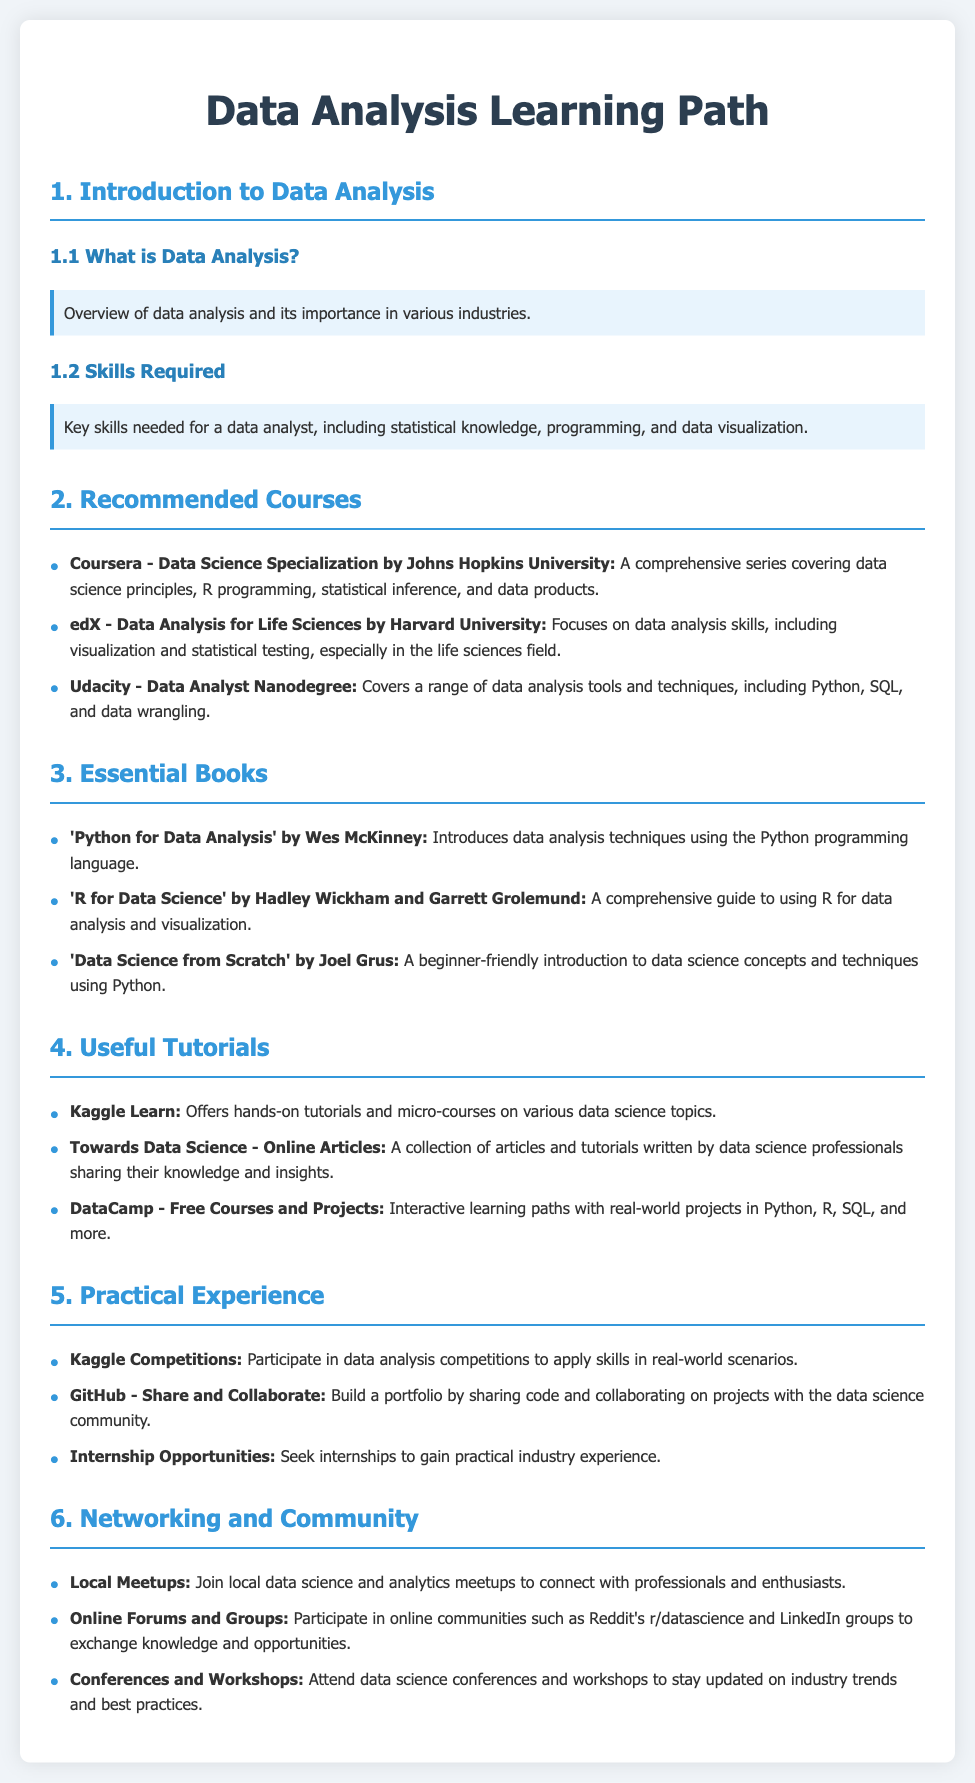What is the title of the document? The title is displayed prominently at the top of the document and reflects its content, focusing on the journey of learning data analysis.
Answer: Data Analysis Learning Path Who authored the Data Science Specialization course? The course is provided by a well-known institution, which is mentioned in the recommendations section for courses.
Answer: Johns Hopkins University What programming language is emphasized in 'Python for Data Analysis'? The book's title specifies the programming language used for data analysis techniques, as mentioned in the essential books section.
Answer: Python Which platform offers the Data Analyst Nanodegree? The platform that provides this nanodegree is mentioned in the recommended courses section, focusing on data analysis tools and techniques.
Answer: Udacity How many essential books are listed? The count of books listed can be found by tallying the entries in the essential books section.
Answer: Three What type of experience can you gain through Kaggle Competitions? The practical experience provided by these competitions is noted in the section related to hands-on activities and skills application.
Answer: Real-world scenarios Which online community is suggested for networking? A specific community platform for data science discussions is listed in the networking and community section.
Answer: Reddit's r/datascience What skill is highlighted as necessary for a data analyst? One of the key skills mentioned in the introduction highlights the importance of this area for success in data analysis roles.
Answer: Statistical knowledge 